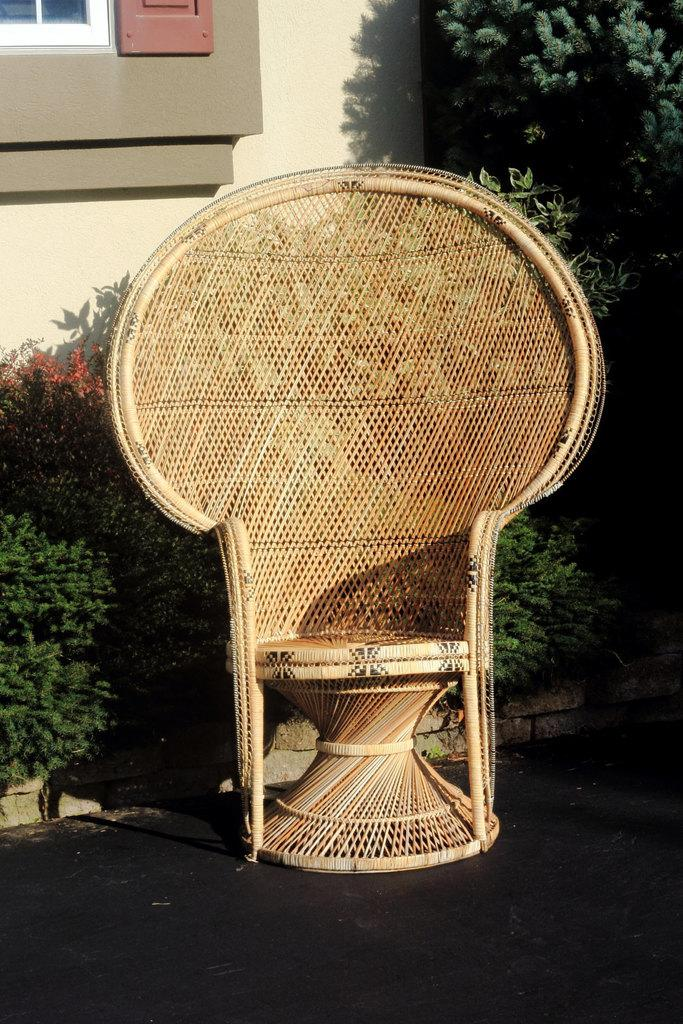What type of furniture can be seen in the image? There is a chair in the image. What can be seen through the window in the image? A window is visible in the image, but the specific view cannot be determined from the facts provided. What type of flora is present in the image? Flowers and plants are present in the image. What type of whistle can be heard in the image? There is no whistle present in the image, and therefore no sound can be heard. What type of linen is draped over the chair in the image? There is no linen mentioned or visible in the image. 